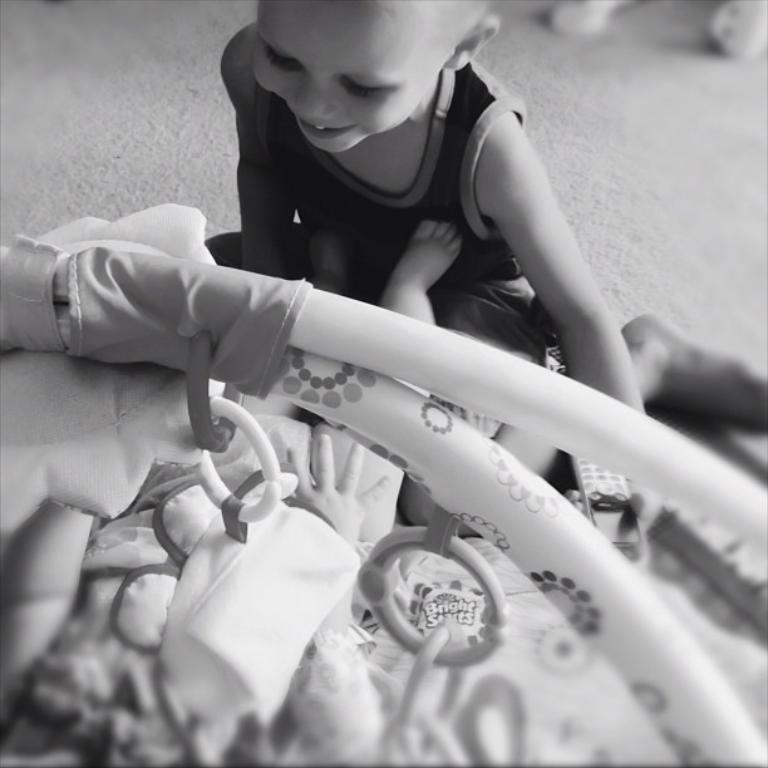What is the main subject of the image? There is a child in the image. What is the child doing in the image? The child is sitting. What other object related to children can be seen in the image? There is a cradle in the image. What is inside the cradle? A baby is present in the cradle. Can you hear the child crying in the image? There is no sound in the image, so it is not possible to determine if the child is crying or not. 